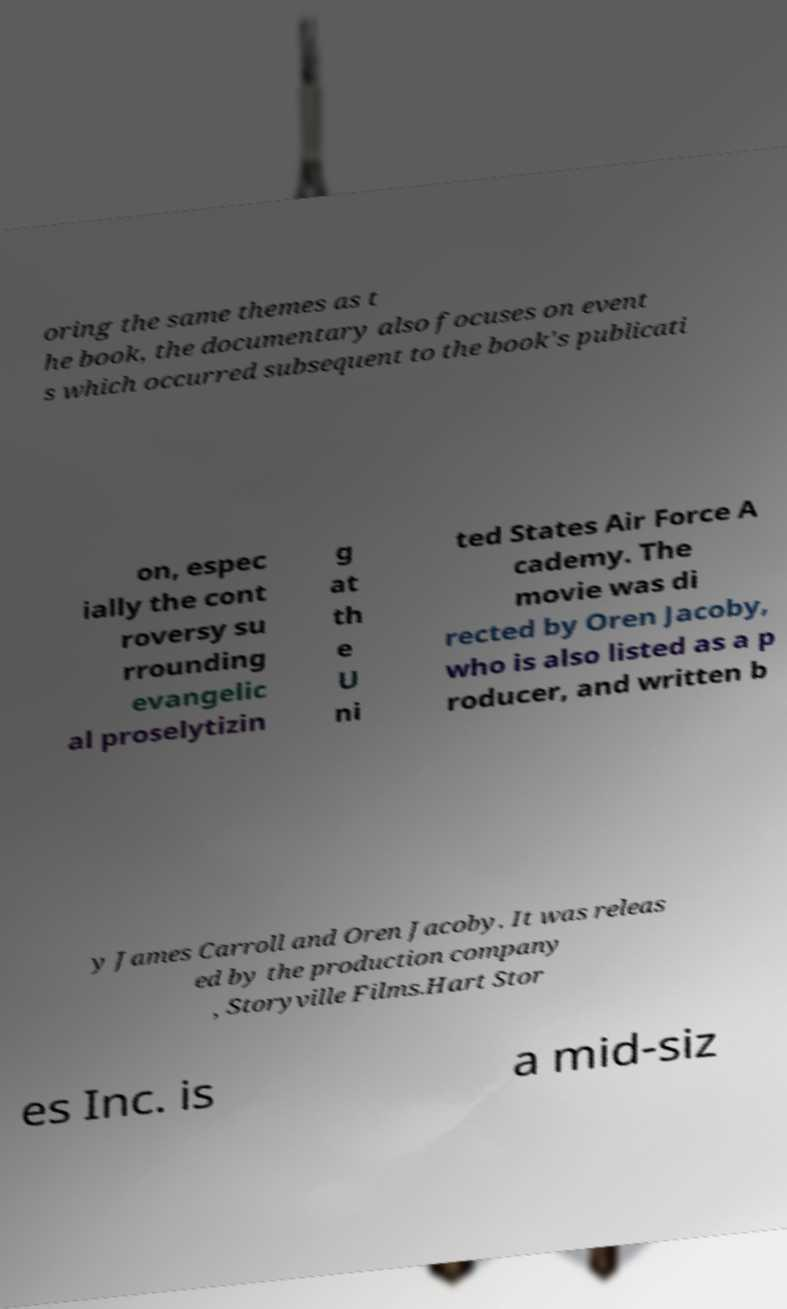For documentation purposes, I need the text within this image transcribed. Could you provide that? oring the same themes as t he book, the documentary also focuses on event s which occurred subsequent to the book's publicati on, espec ially the cont roversy su rrounding evangelic al proselytizin g at th e U ni ted States Air Force A cademy. The movie was di rected by Oren Jacoby, who is also listed as a p roducer, and written b y James Carroll and Oren Jacoby. It was releas ed by the production company , Storyville Films.Hart Stor es Inc. is a mid-siz 